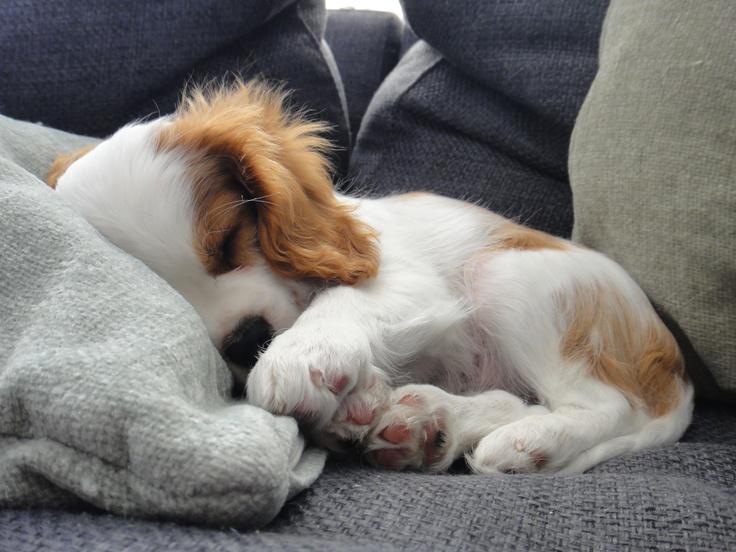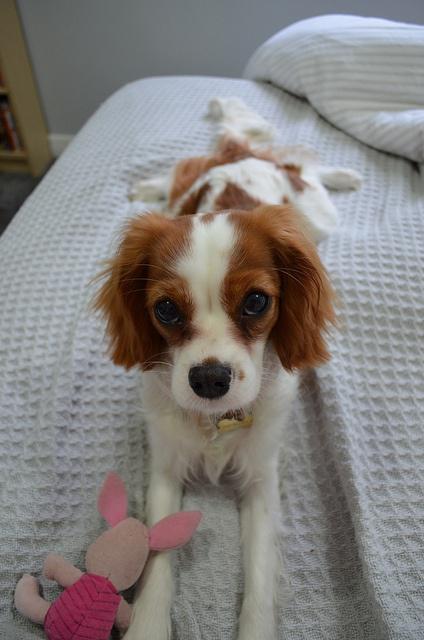The first image is the image on the left, the second image is the image on the right. For the images displayed, is the sentence "One of the puppies is laying the side of its head against a blanket." factually correct? Answer yes or no. Yes. 